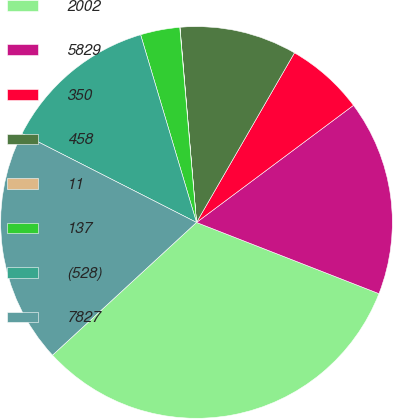<chart> <loc_0><loc_0><loc_500><loc_500><pie_chart><fcel>2002<fcel>5829<fcel>350<fcel>458<fcel>11<fcel>137<fcel>(528)<fcel>7827<nl><fcel>32.22%<fcel>16.12%<fcel>6.46%<fcel>9.68%<fcel>0.02%<fcel>3.24%<fcel>12.9%<fcel>19.34%<nl></chart> 